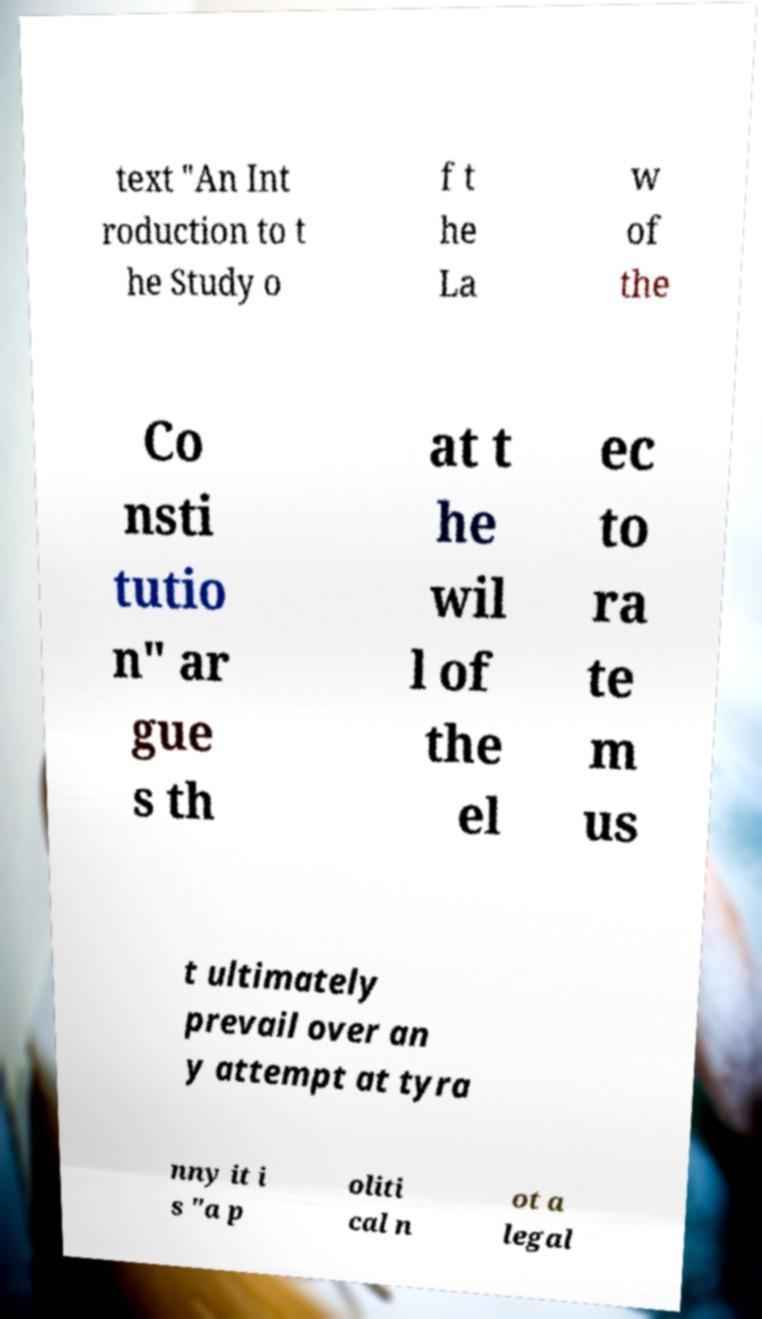I need the written content from this picture converted into text. Can you do that? text "An Int roduction to t he Study o f t he La w of the Co nsti tutio n" ar gue s th at t he wil l of the el ec to ra te m us t ultimately prevail over an y attempt at tyra nny it i s "a p oliti cal n ot a legal 